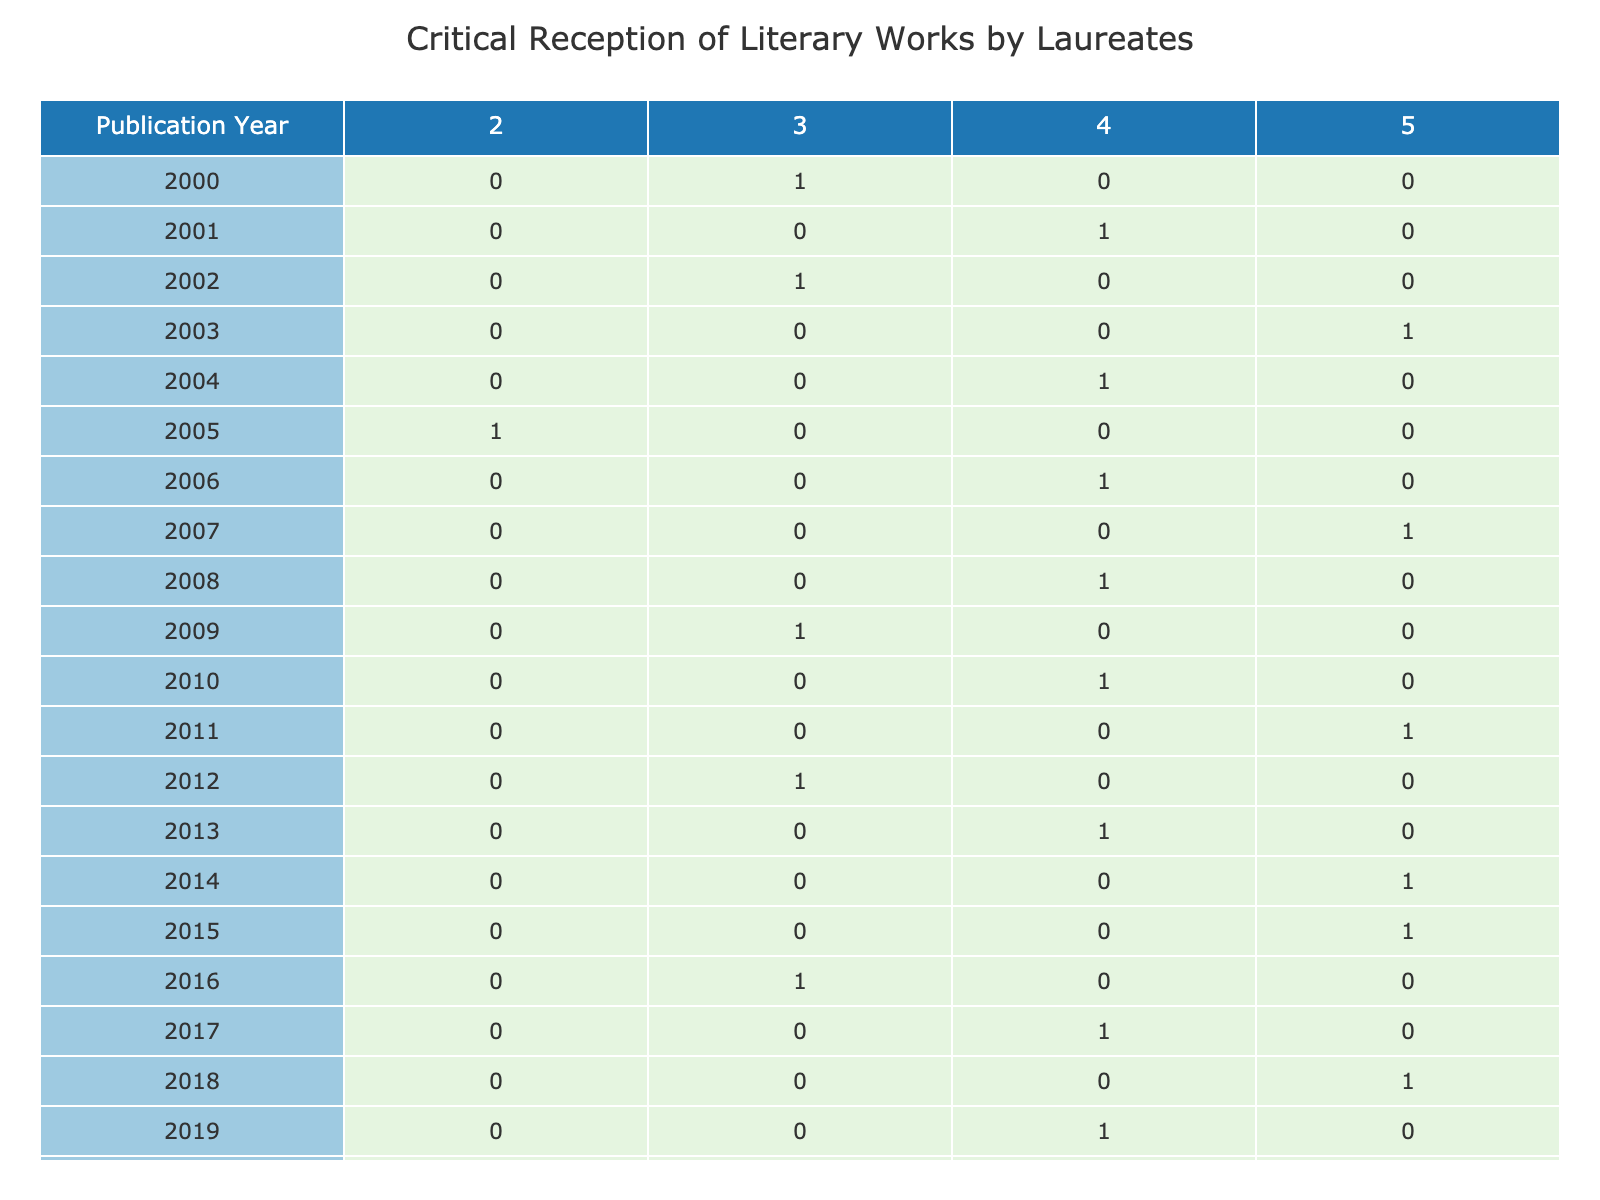What is the highest critical rating given to a literary work published in 2006? The table shows that in 2006, Orhan Pamuk's "Snow" received a critical rating of 4, which is the highest rating in that year, with no higher ratings recorded for that year.
Answer: 4 How many literary works received a critical rating of 5 in the publication year 2018? Referring to the table for the year 2018, Olga Tokarczuk's "The Books of Jacob" is the only work listed, and it received a critical rating of 5. Therefore, there is only one work with that rating in 2018.
Answer: 1 What is the average critical rating for literary works published between 2000 and 2010? To find the average, we first add the critical ratings for the publication years 2000 to 2010: (3 + 4 + 3 + 5 + 4 + 2 + 4 + 5 + 4 + 3) = 43. The total number of works in that range is 10. Thus, the average rating is 43/10 = 4.3.
Answer: 4.3 Was there any year between 2000 and 2020 where no literary work received a rating of 2? By examining the table, the only year recording a rating of 2 is 2005, as all other years show ratings of 3 and higher. Hence, all other years between 2000 and 2020 did not have a work rated 2.
Answer: Yes What is the total number of works published with a critical rating of 3 from 2000 to 2020? The years and works that received a rating of 3 are: 2000 (1), 2002 (1), 2009 (1), and 2012 (1). Adding these, there are 4 works that received a critical rating of 3, summing the values from each relevant year. Therefore, the total number of works is 4.
Answer: 4 